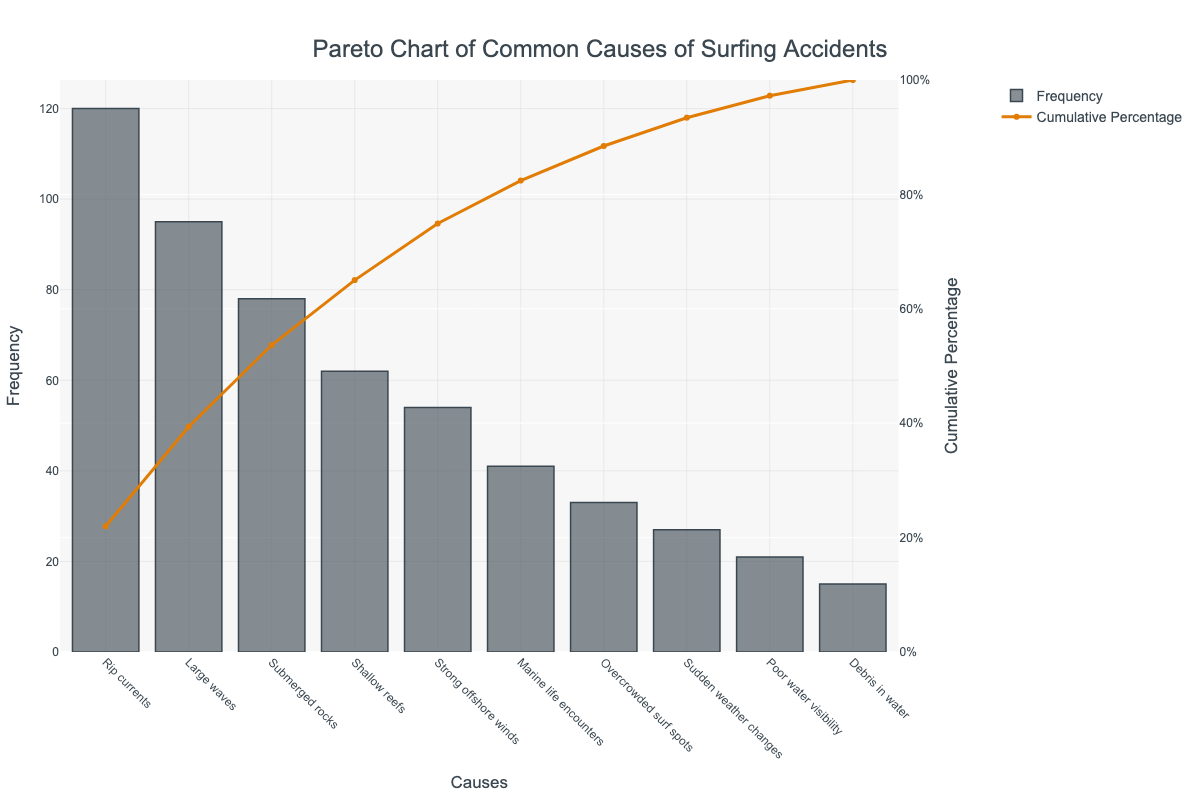1. What is the title of the chart? The title is located at the top center of the chart, usually in a larger font size, making it easy to identify.
Answer: Pareto Chart of Common Causes of Surfing Accidents 2. Which cause has the highest frequency of surfing accidents? By visually inspecting the bar chart, the tallest bar represents the cause with the highest frequency.
Answer: Rip currents 3. What is the combined frequency of accidents caused by large waves and submerged rocks? Identify the frequencies for 'Large waves' (95) and 'Submerged rocks' (78) from the bar chart and sum them. 95 + 78 = 173
Answer: 173 4. How much higher is the frequency of rip currents compared to marine life encounters? Subtract the frequency of 'Marine life encounters' (41) from 'Rip currents' (120). 120 - 41 = 79
Answer: 79 5. Which cause is responsible for about half of the cumulative percentage? Look for the cause at around the 50% mark on the cumulative percentage line, which corresponds to the higher value on the y-axis on the right side.
Answer: Submerged rocks 6. What is the cumulative percentage after accounting for the top four causes of surfing accidents? Add up the cumulative percentages of the top four causes: Rip currents, Large waves, Submerged rocks, and Shallow reefs. 45% (Rip currents) + 80% (Large waves and Submerged rocks) + 95% (Shallow reefs)
Answer: 85% 7. Which environmental factors contribute to more than 50% of the accidents cumulatively? Check where the cumulative percentage exceeds 50%, which includes Rip currents, Large waves, and Submerged rocks.
Answer: Rip currents, Large waves, Submerged rocks 8. Between overcrowded surf spots and poor water visibility, which cause is more frequent? Compare the heights of the bars for 'Overcrowded surf spots' (33) and 'Poor water visibility' (21).
Answer: Overcrowded surf spots 9. Which environmental factor has the lowest frequency of surfing accidents? Identify the shortest bar on the chart, which represents the cause with the lowest frequency.
Answer: Debris in water 10. By how much does the frequency of large waves exceed that of debris in water? Subtract the frequency of 'Debris in water' (15) from 'Large waves' (95). 95 - 15 = 80
Answer: 80 